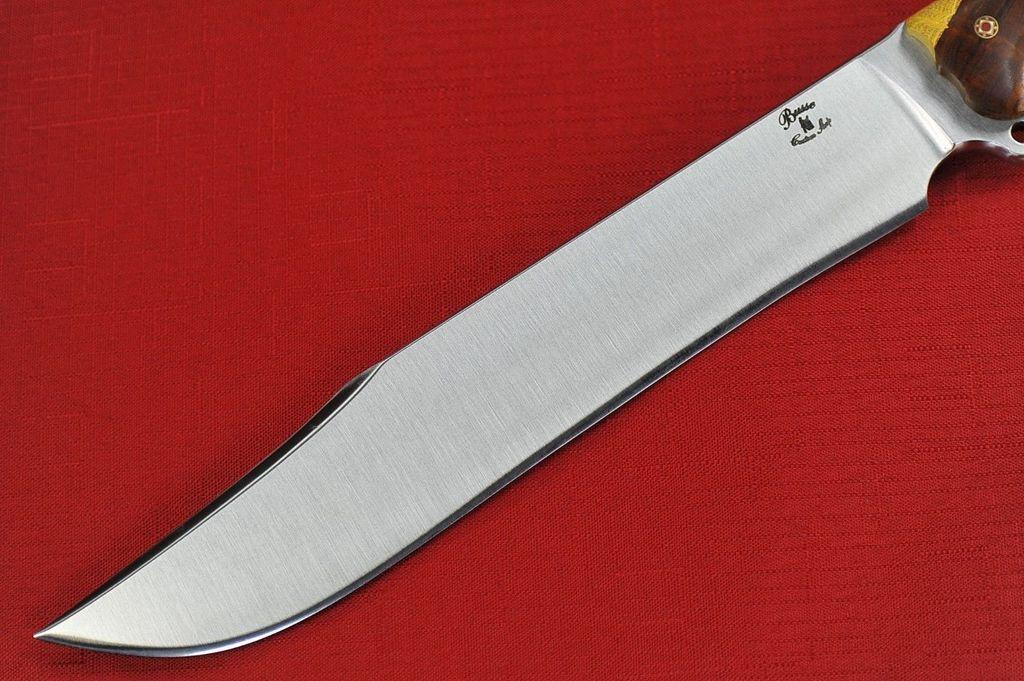How would you summarize this image in a sentence or two? The picture consists of a dagger on a red color cloth. 